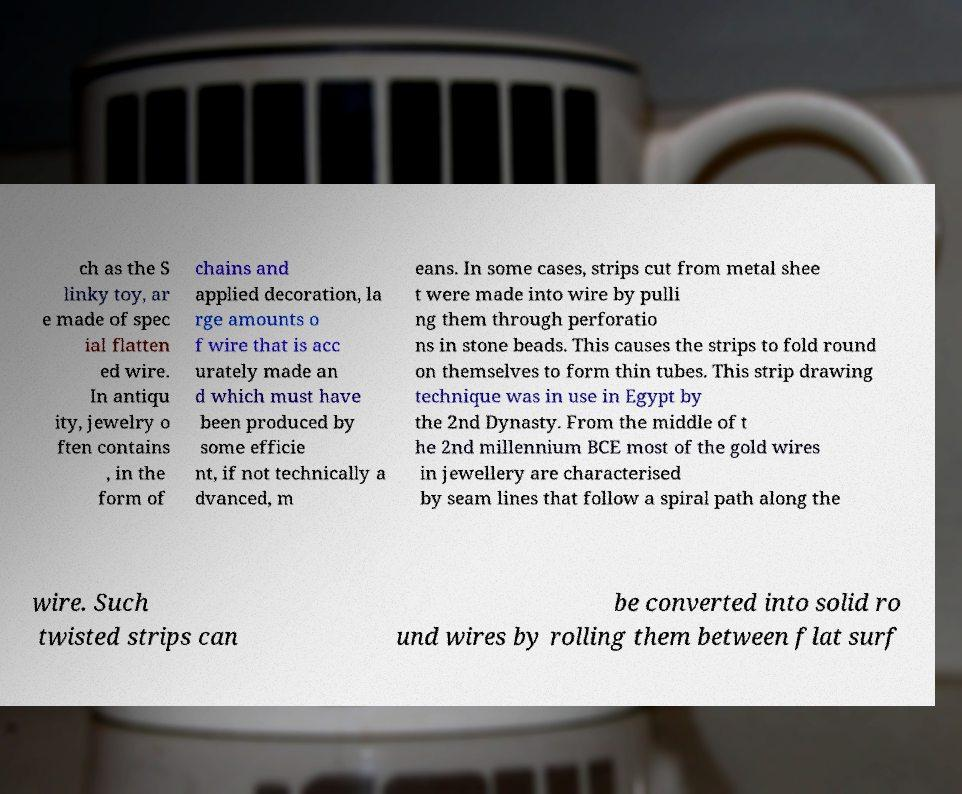For documentation purposes, I need the text within this image transcribed. Could you provide that? ch as the S linky toy, ar e made of spec ial flatten ed wire. In antiqu ity, jewelry o ften contains , in the form of chains and applied decoration, la rge amounts o f wire that is acc urately made an d which must have been produced by some efficie nt, if not technically a dvanced, m eans. In some cases, strips cut from metal shee t were made into wire by pulli ng them through perforatio ns in stone beads. This causes the strips to fold round on themselves to form thin tubes. This strip drawing technique was in use in Egypt by the 2nd Dynasty. From the middle of t he 2nd millennium BCE most of the gold wires in jewellery are characterised by seam lines that follow a spiral path along the wire. Such twisted strips can be converted into solid ro und wires by rolling them between flat surf 